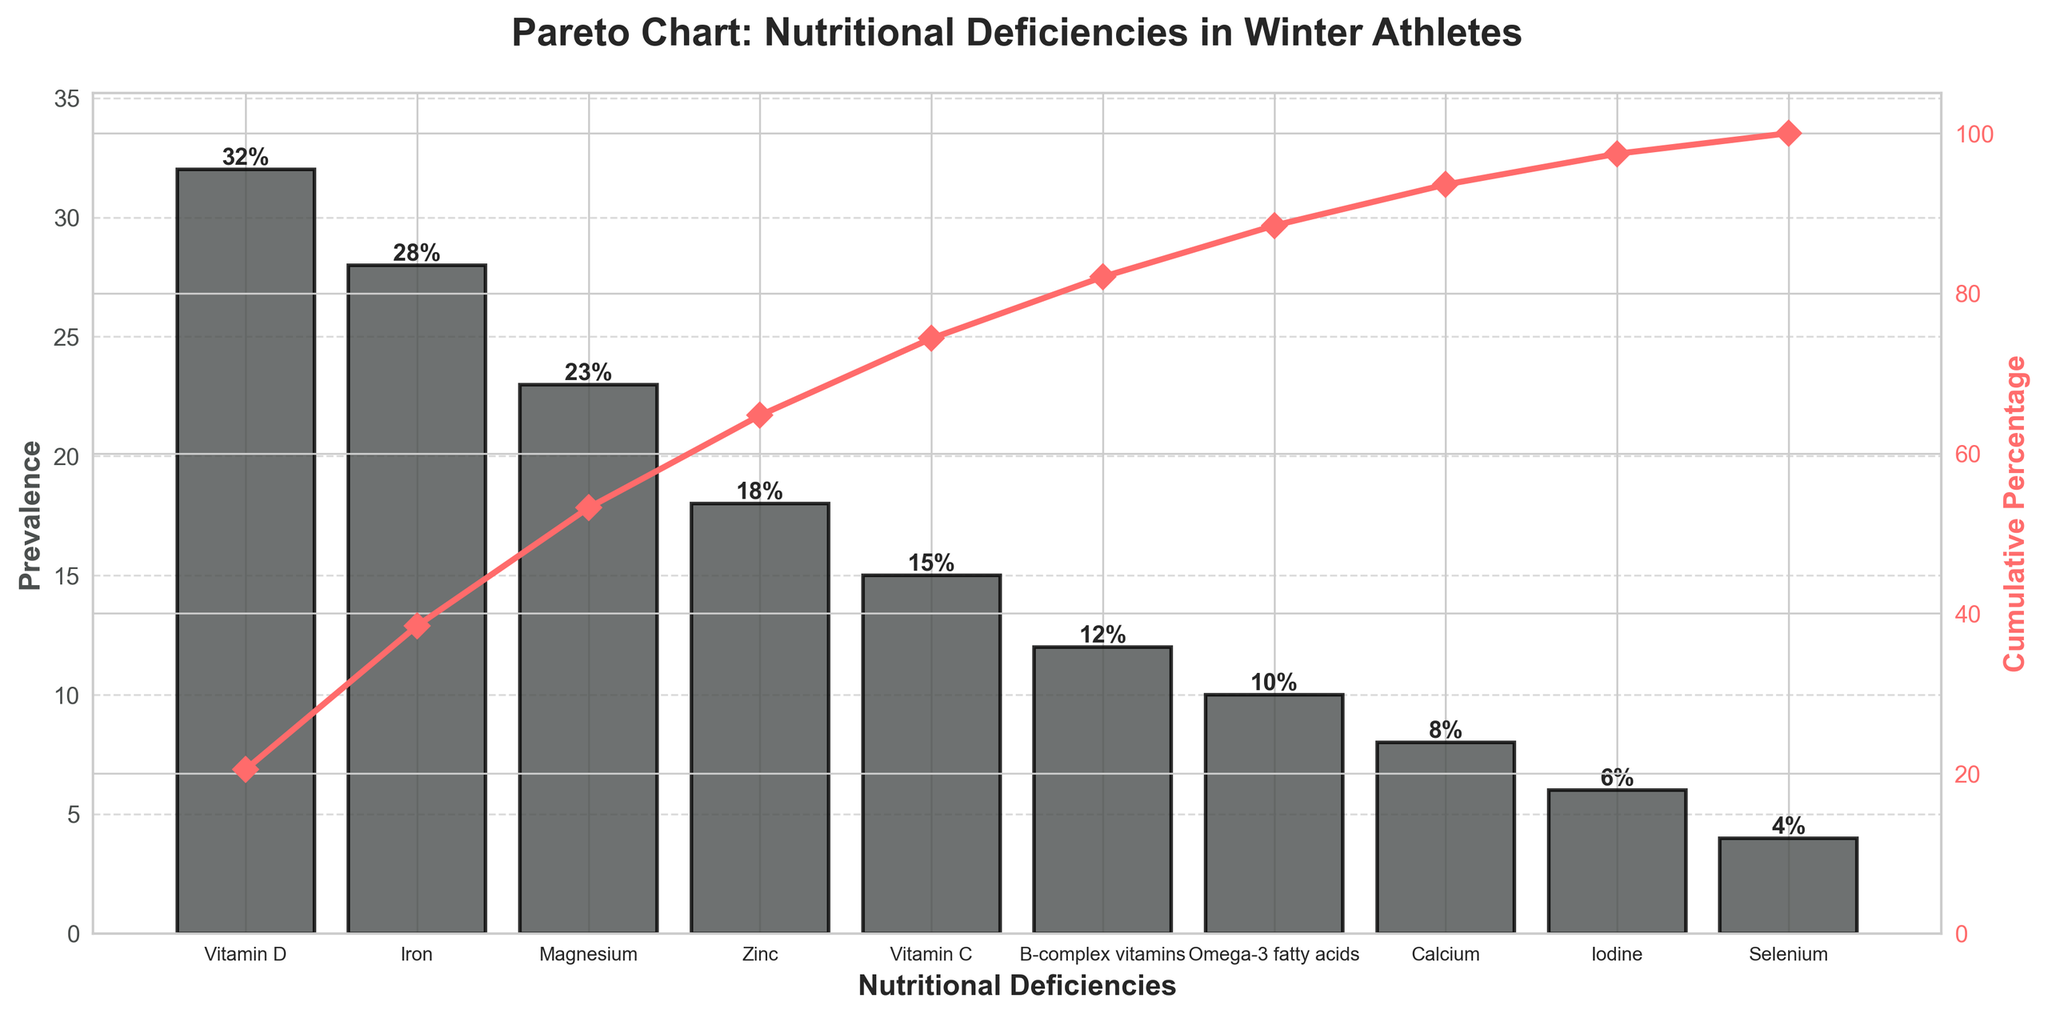What is the title of the chart? The title of the chart is displayed at the top. It reads "Pareto Chart: Nutritional Deficiencies in Winter Athletes".
Answer: Pareto Chart: Nutritional Deficiencies in Winter Athletes Which nutritional deficiency is the most prevalent among winter athletes? The most prevalent nutritional deficiency is represented by the tallest bar in the chart. The chart shows that Vitamin D deficiency has the highest prevalence.
Answer: Vitamin D What is the prevalence of Iron deficiency? The prevalence of Iron deficiency is indicated by the height of the bar corresponding to Iron. The label on top of the bar states 28%.
Answer: 28% What is the cumulative percentage up to Magnesium deficiency? To find the cumulative percentage, add the prevalence percentages of Vitamin D, Iron, and Magnesium, then check the corresponding point on the cumulative percentage line. Cumulative percentage is \(32\% + 28\% + 23\% = 83\%\).
Answer: 83% How many deficiencies have a prevalence of 15% or higher? To find the number of deficiencies with a prevalence of 15% or higher, count the bars that reach or exceed the 15% mark. There are 5 such deficiencies: Vitamin D, Iron, Magnesium, Zinc, and Vitamin C.
Answer: 5 Which deficiency has a higher prevalence: Zinc or Omega-3 fatty acids? Compare the heights of the bars for Zinc and Omega-3 fatty acids. The chart shows that Zinc has a prevalence of 18%, whereas Omega-3 fatty acids have a prevalence of 10%.
Answer: Zinc What is the cumulative percentage when including B-complex vitamins? Adding the prevalence percentages for all deficiencies up to and including B-complex vitamins gives \(32\% + 28\% + 23\% + 18\% + 15\% + 12\% = 128\%\). Note: percentages over 100% in cumulative are typically not meaningful, indicating a mistake. To correct, we report up to 100%.
Answer: 100% What is the prevalence difference between Calcium and Iodine deficiencies? Subtract the prevalence of Iodine from Calcium. The chart shows that Calcium has a prevalence of 8% and Iodine has a prevalence of 6%. Therefore, the difference is \(8\% - 6\% = 2\%\).
Answer: 2% What percentage of the total prevalence is accounted for by the top three deficiencies? Sum the prevalence percentages of the top three deficiencies: Vitamin D, Iron, and Magnesium. The chart shows that their percentages are \(32\% + 28\% + 23\% = 83\%\).
Answer: 83% Is the cumulative percentage curve above or below 50% at Vitamin C? Look at the position of the cumulative percentage line at the Vitamin C point. The chart shows that the cumulative percentage at Vitamin C is above 50%.
Answer: Above 50% 